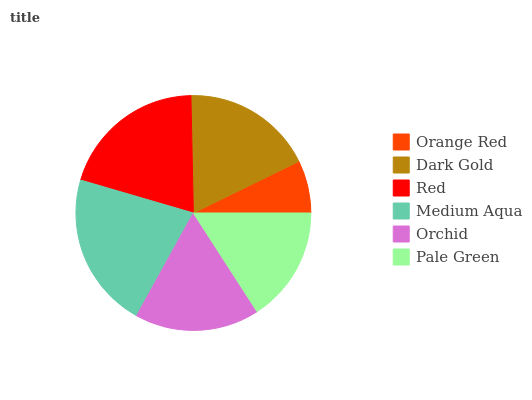Is Orange Red the minimum?
Answer yes or no. Yes. Is Medium Aqua the maximum?
Answer yes or no. Yes. Is Dark Gold the minimum?
Answer yes or no. No. Is Dark Gold the maximum?
Answer yes or no. No. Is Dark Gold greater than Orange Red?
Answer yes or no. Yes. Is Orange Red less than Dark Gold?
Answer yes or no. Yes. Is Orange Red greater than Dark Gold?
Answer yes or no. No. Is Dark Gold less than Orange Red?
Answer yes or no. No. Is Dark Gold the high median?
Answer yes or no. Yes. Is Orchid the low median?
Answer yes or no. Yes. Is Medium Aqua the high median?
Answer yes or no. No. Is Pale Green the low median?
Answer yes or no. No. 